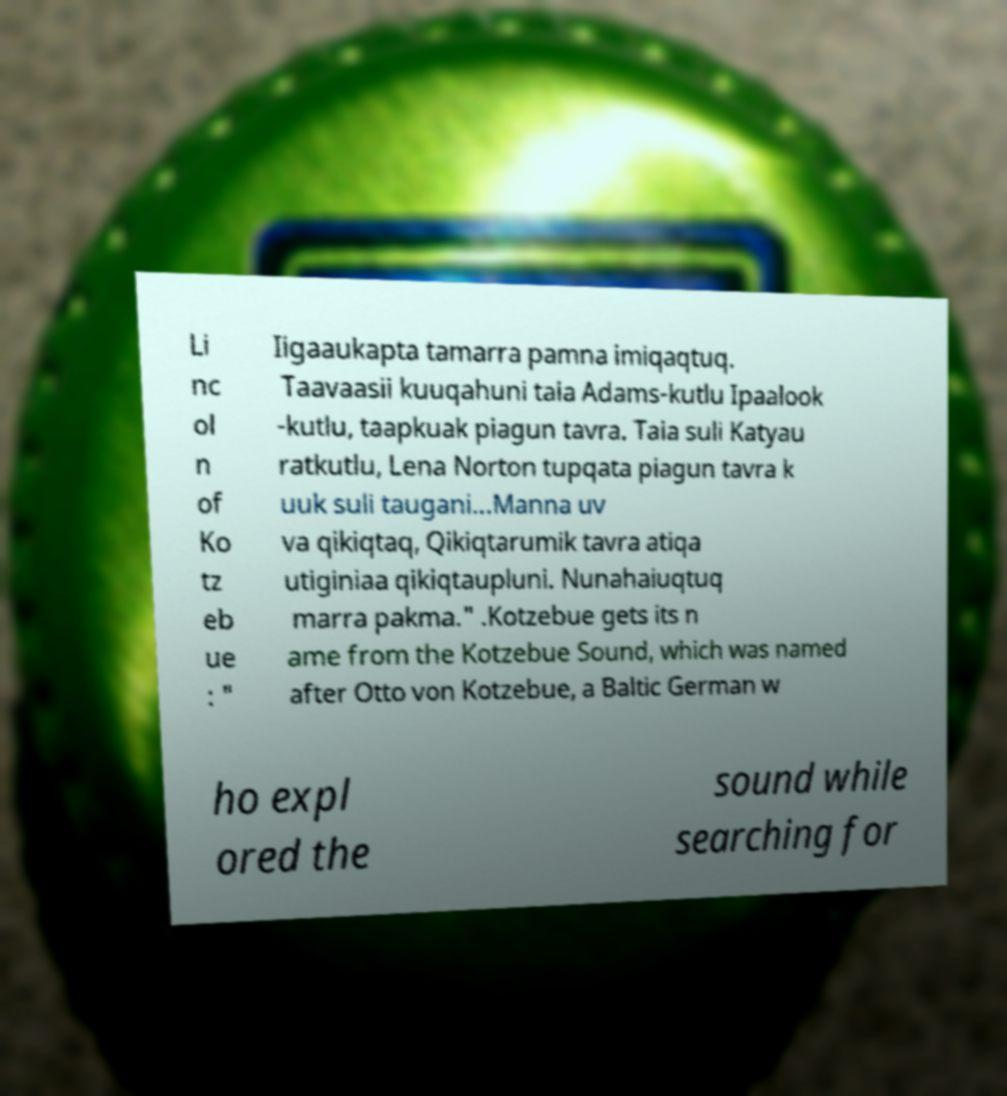Can you accurately transcribe the text from the provided image for me? Li nc ol n of Ko tz eb ue : " Iigaaukapta tamarra pamna imiqaqtuq. Taavaasii kuuqahuni taia Adams-kutlu Ipaalook -kutlu, taapkuak piagun tavra. Taia suli Katyau ratkutlu, Lena Norton tupqata piagun tavra k uuk suli taugani...Manna uv va qikiqtaq, Qikiqtarumik tavra atiqa utiginiaa qikiqtaupluni. Nunahaiuqtuq marra pakma." .Kotzebue gets its n ame from the Kotzebue Sound, which was named after Otto von Kotzebue, a Baltic German w ho expl ored the sound while searching for 